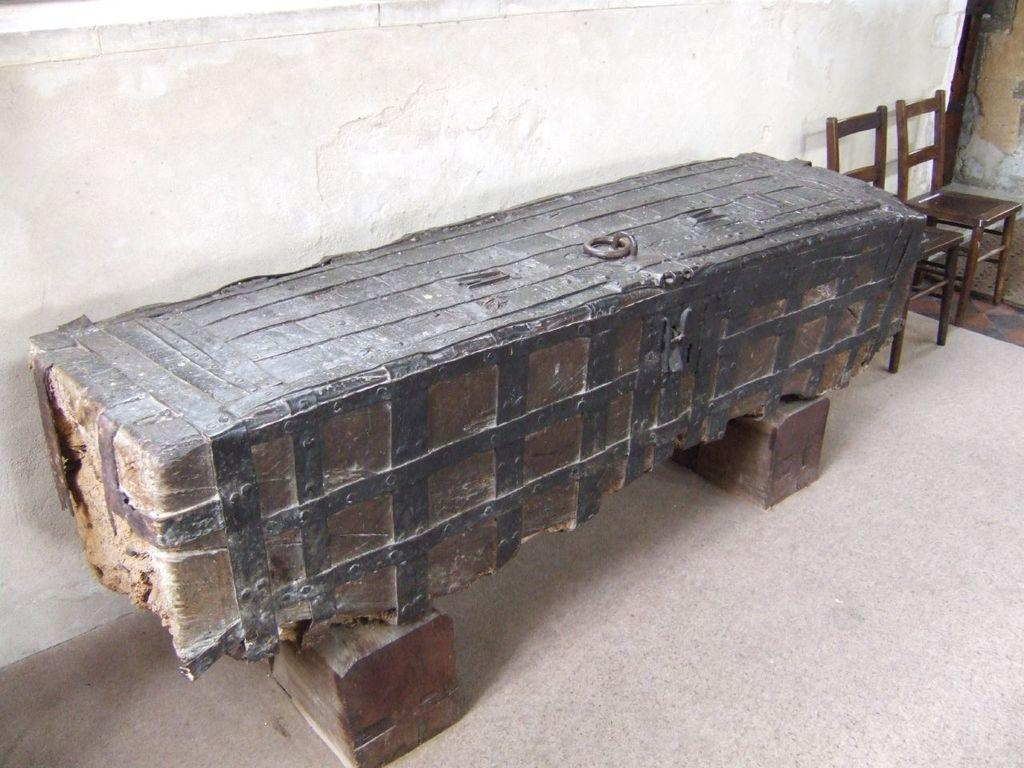What type of furniture is present in the image? There are chairs in the image. What is the main object in the image? There is a wooden trunk in the image. What is the background made of in the image? There is a wall in the image. What is the surface that the wooden trunk and chairs are placed on? There is a floor in the image. How many legs can be seen on the wooden trunk in the image? The wooden trunk in the image does not have legs; it is resting on the floor. What type of container is used for holding items in the image? There is no basket present in the image. 